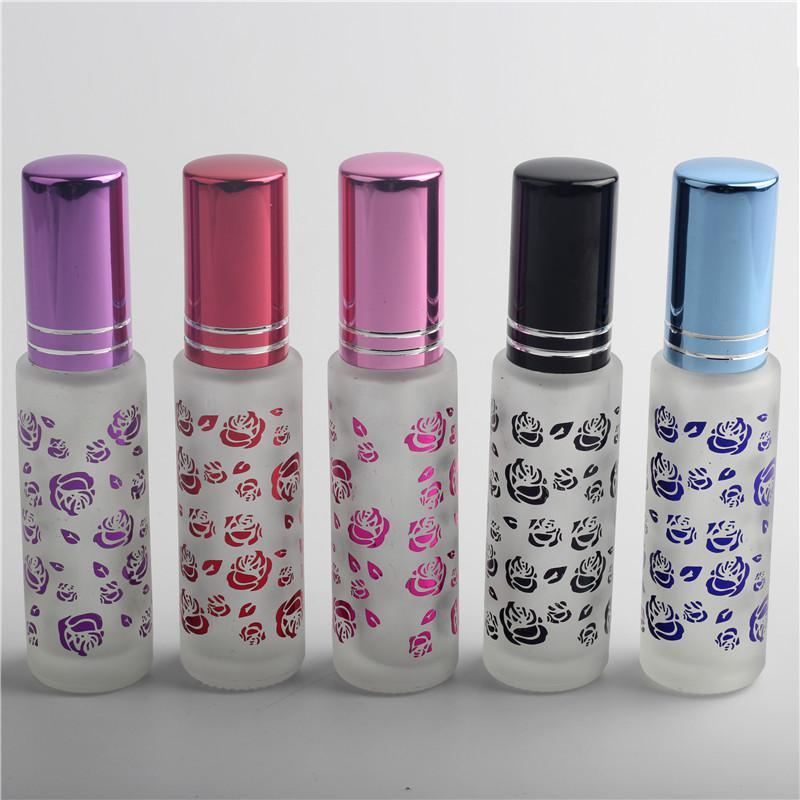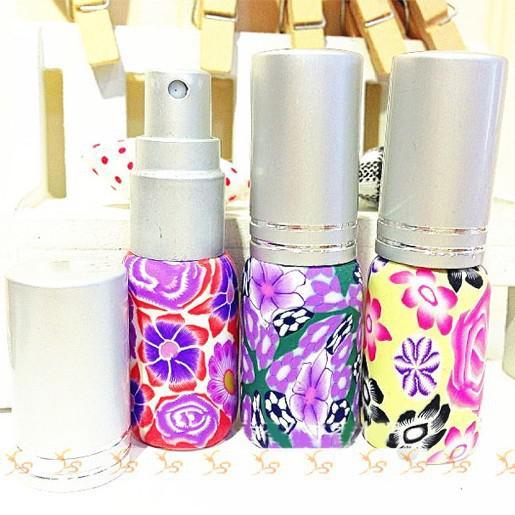The first image is the image on the left, the second image is the image on the right. Evaluate the accuracy of this statement regarding the images: "All products are standing upright.". Is it true? Answer yes or no. Yes. The first image is the image on the left, the second image is the image on the right. Evaluate the accuracy of this statement regarding the images: "One image includes a row of at least three clear glass fragrance bottles with tall metallic caps, and the other image includes several roundish bottles with round caps.". Is it true? Answer yes or no. No. 